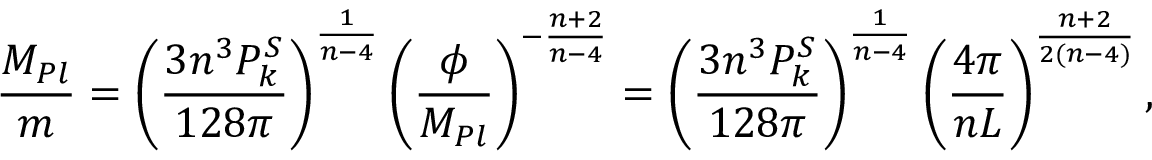Convert formula to latex. <formula><loc_0><loc_0><loc_500><loc_500>{ \frac { M _ { P l } } { m } } = \left ( { \frac { 3 n ^ { 3 } P _ { k } ^ { S } } { 1 2 8 \pi } } \right ) ^ { { \frac { 1 } { n - 4 } } } \left ( { \frac { \phi } { M _ { P l } } } \right ) ^ { - { \frac { n + 2 } { n - 4 } } } = \left ( { \frac { 3 n ^ { 3 } P _ { k } ^ { S } } { 1 2 8 \pi } } \right ) ^ { { \frac { 1 } { n - 4 } } } \left ( { \frac { 4 \pi } { n L } } \right ) ^ { { \frac { n + 2 } { 2 ( n - 4 ) } } } ,</formula> 